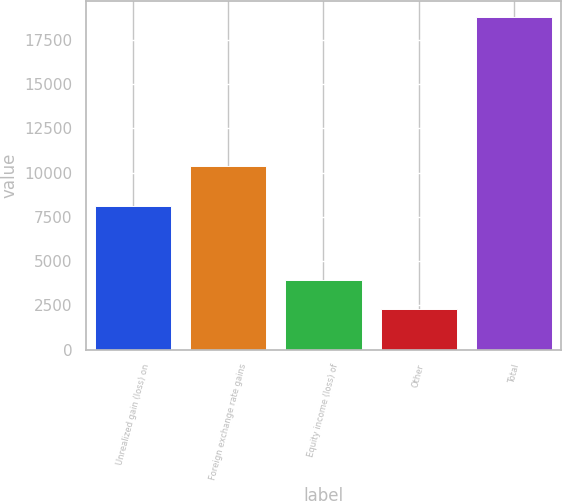Convert chart. <chart><loc_0><loc_0><loc_500><loc_500><bar_chart><fcel>Unrealized gain (loss) on<fcel>Foreign exchange rate gains<fcel>Equity income (loss) of<fcel>Other<fcel>Total<nl><fcel>8137<fcel>10367<fcel>3924.5<fcel>2275<fcel>18770<nl></chart> 